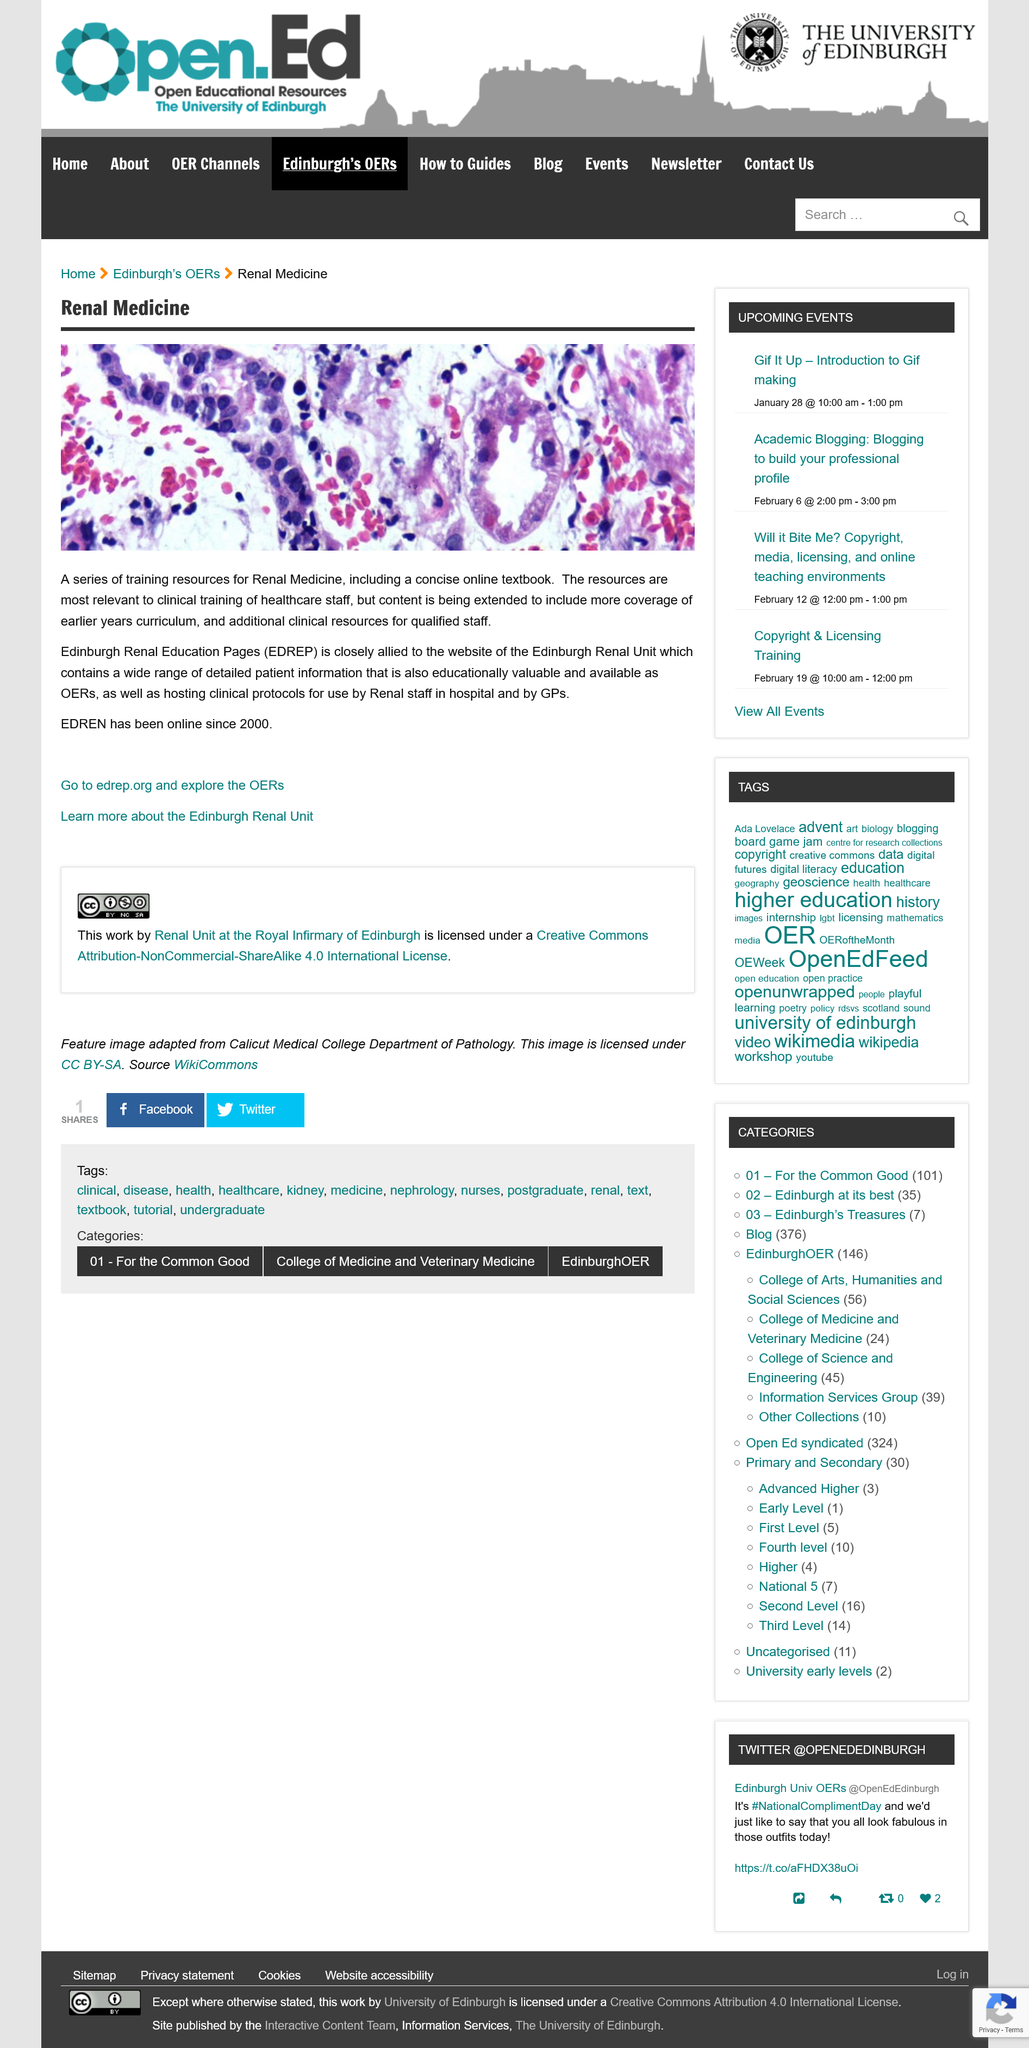Mention a couple of crucial points in this snapshot. Since 2000, EDREN has been online. EDREP stands for the Edinburgh Renal Education Pages. The Edinburgh Renal Unit's website is utilized by both renal staff at hospitals and general practitioners (GPs) to access the resources available. 